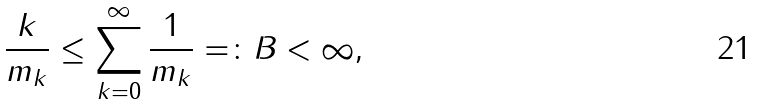Convert formula to latex. <formula><loc_0><loc_0><loc_500><loc_500>\frac { k } { m _ { k } } \leq \sum _ { k = 0 } ^ { \infty } \frac { 1 } { m _ { k } } = \colon B < \infty ,</formula> 